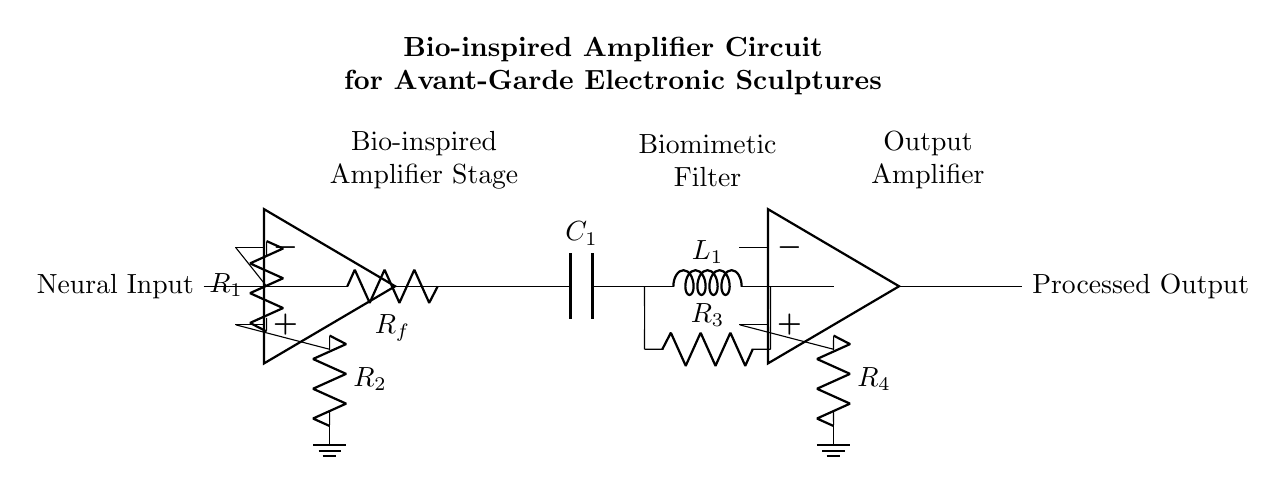What is the type of the first amplifier used in the circuit? The first amplifier is an operational amplifier, often abbreviated as op amp, which is indicated by the symbol used in the diagram.
Answer: operational amplifier What component provides feedback to the first amplifier? The feedback is provided by the resistor labeled Rf, which connects the output of the first op amp back to its inverting input.
Answer: Rf What types of components make up the biomimetic filter? The biomimetic filter consists of a capacitor labeled C1, an inductor labeled L1, and a resistor labeled R3, as shown in the circuit.
Answer: C1, L1, R3 How many stages are there in the amplifier configuration? The circuit shows a total of two amplifier stages, with a biomimetic filter between them, which can be counted visually in the diagram.
Answer: two What role does the resistor R2 play in the first stage of the amplifier? Resistor R2 is part of the input stage of the first amplifier, and it acts as a feedback and gain setting component that influences the amplifier's output.
Answer: feedback What is the output of the second amplifier stage? The output of the second amplifier stage is represented as 'Processed Output' in the diagram, which indicates the final output of the circuit.
Answer: Processed Output Which components are connected to the output terminal of the second stage amplifier? The output terminal is directly outputting the processed signal without passing through additional components after the second op amp.
Answer: none 